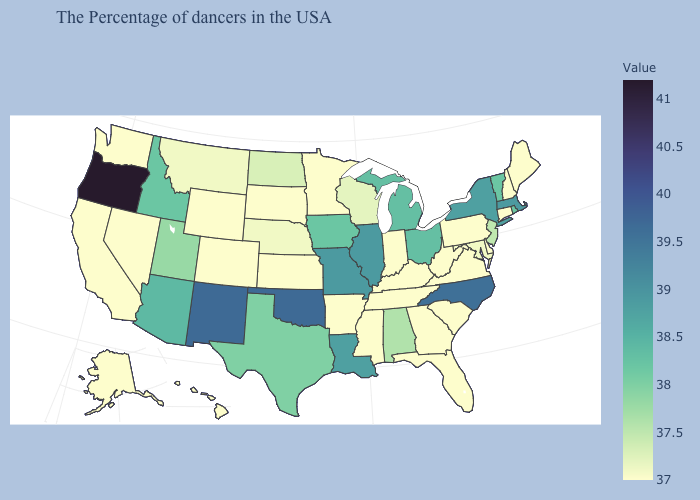Among the states that border Connecticut , does Massachusetts have the highest value?
Quick response, please. Yes. Which states have the lowest value in the USA?
Short answer required. Maine, New Hampshire, Connecticut, Delaware, Pennsylvania, Virginia, South Carolina, West Virginia, Florida, Georgia, Kentucky, Indiana, Tennessee, Mississippi, Arkansas, Minnesota, Kansas, South Dakota, Wyoming, Colorado, Nevada, California, Washington, Alaska, Hawaii. Does New Jersey have the highest value in the USA?
Keep it brief. No. Does New Mexico have the lowest value in the USA?
Be succinct. No. Among the states that border Tennessee , which have the highest value?
Give a very brief answer. North Carolina. 